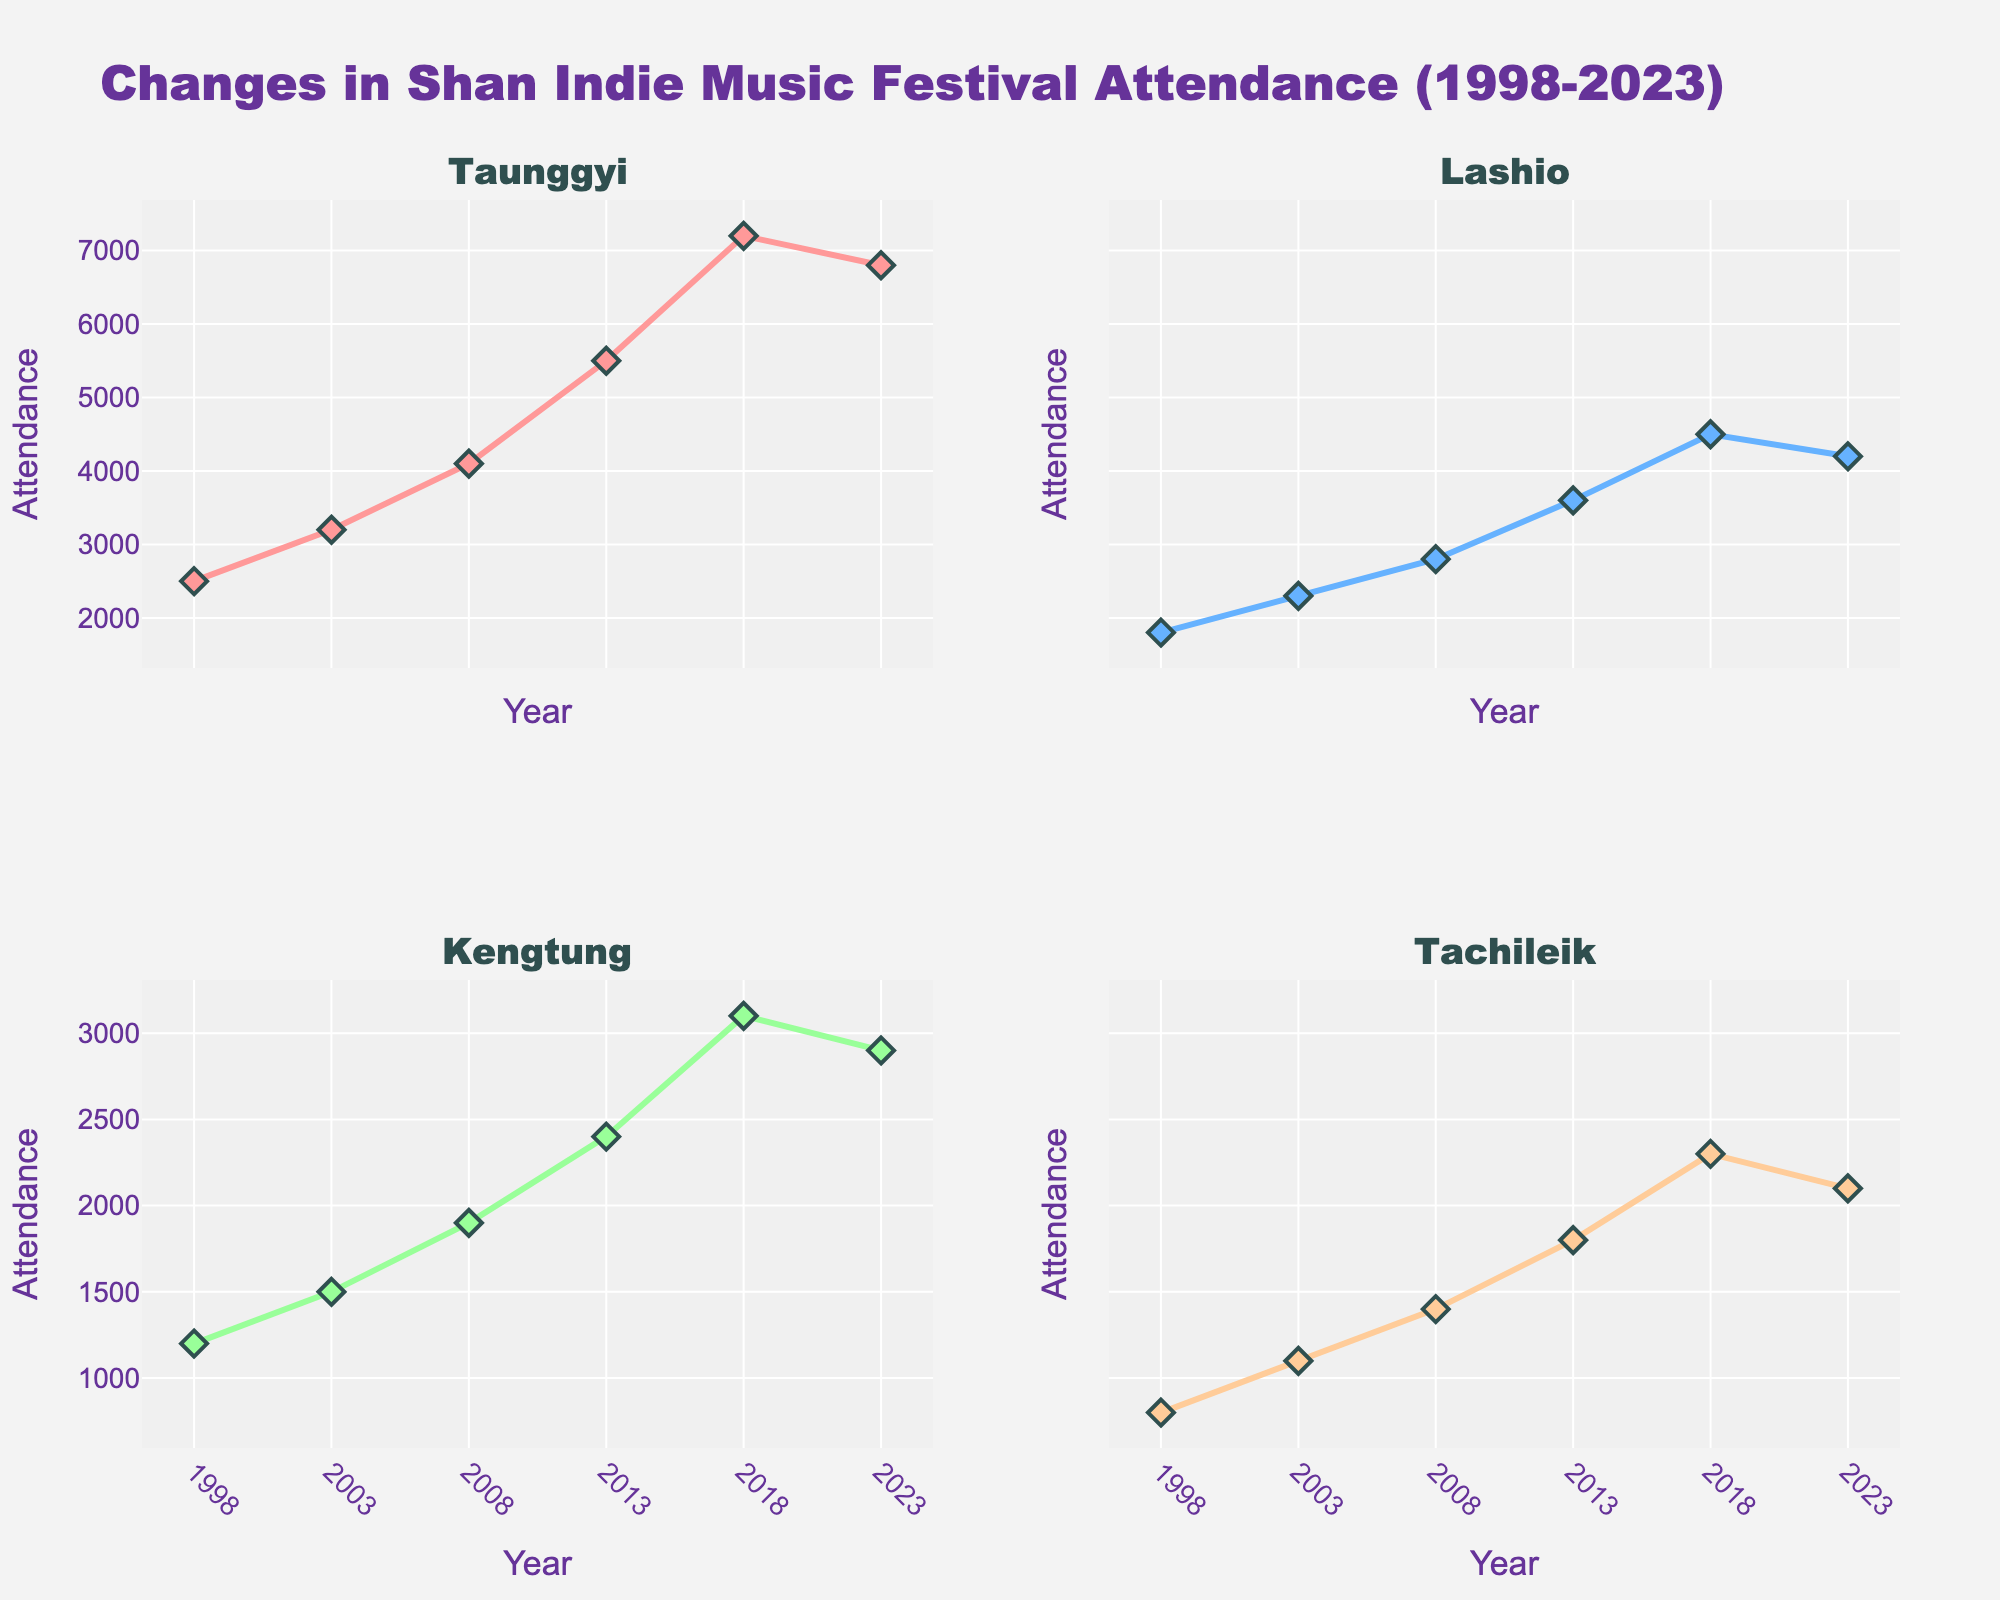What is the title of the figure? The title is at the top of the figure. It reads "Changes in Shan Indie Music Festival Attendance (1998-2023)."
Answer: Changes in Shan Indie Music Festival Attendance (1998-2023) How many years are included in the data? The x-axis shows six data points, each corresponding to a year: 1998, 2003, 2008, 2013, 2018, and 2023.
Answer: 6 Which city had the highest concert attendance in 2018? Look at the data point for 2018 across all four subplots. Taunggyi has the highest value (7200) in that year.
Answer: Taunggyi What is the overall trend for concert attendance in Kengtung from 1998 to 2023? The line for Kengtung starts in 1998 at an attendance of 1200, increases to 3100 in 2018, and slightly decreases to 2900 in 2023. The overall trend shows an increase.
Answer: Increasing Which year saw the peak attendance in Taunggyi? The line for Taunggyi peaks in 2018 with the highest attendance at 7200.
Answer: 2018 What is the difference in concert attendance between Lashio and Tachileik in 2008? Look at 2008 data points for Lashio (2800) and Tachileik (1400). The difference is 2800 - 1400.
Answer: 1400 Which city experienced a decline in attendance between 2018 and 2023? Compare 2018 and 2023 data points for all cities. Taunggyi, Lashio, Kengtung, and Tachileik all show a decline in attendance.
Answer: Taunggyi, Lashio, Kengtung, Tachileik How does Taunggyi's concert attendance in 2023 compare to its attendance in 1998? Taunggyi's attendance in 1998 was 2500 and in 2023 is 6800. 6800 is greater than 2500 indicating an increase.
Answer: Increased What's the average concert attendance in Tachileik for the years given? Attendance values in Tachileik are 800, 1100, 1400, 1800, 2300, and 2100. Sum these and divide by the number of years: (800 + 1100 + 1400 + 1800 + 2300 + 2100) / 6 = 9500 / 6 = 1583.33
Answer: 1583.33 